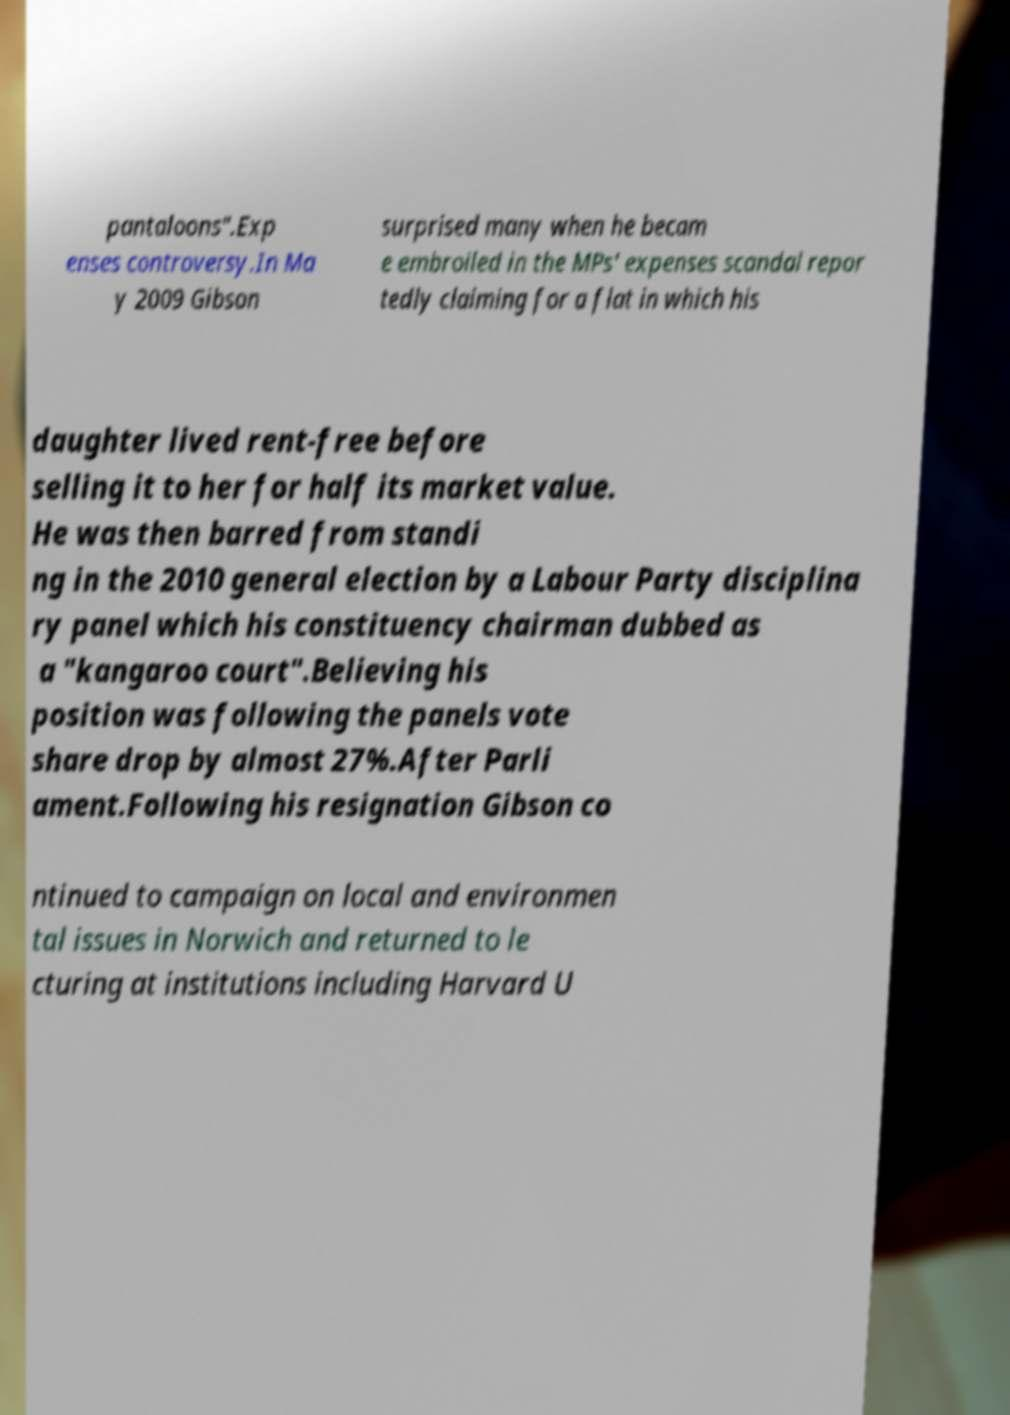Can you read and provide the text displayed in the image?This photo seems to have some interesting text. Can you extract and type it out for me? pantaloons".Exp enses controversy.In Ma y 2009 Gibson surprised many when he becam e embroiled in the MPs' expenses scandal repor tedly claiming for a flat in which his daughter lived rent-free before selling it to her for half its market value. He was then barred from standi ng in the 2010 general election by a Labour Party disciplina ry panel which his constituency chairman dubbed as a "kangaroo court".Believing his position was following the panels vote share drop by almost 27%.After Parli ament.Following his resignation Gibson co ntinued to campaign on local and environmen tal issues in Norwich and returned to le cturing at institutions including Harvard U 